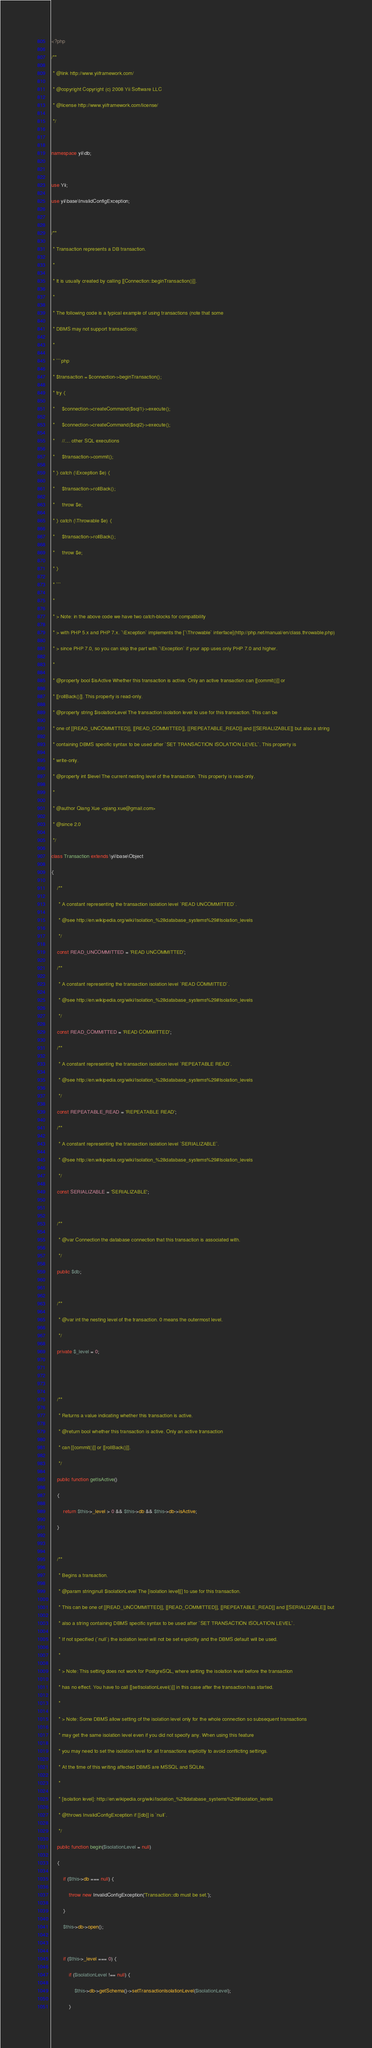Convert code to text. <code><loc_0><loc_0><loc_500><loc_500><_PHP_><?php
/**
 * @link http://www.yiiframework.com/
 * @copyright Copyright (c) 2008 Yii Software LLC
 * @license http://www.yiiframework.com/license/
 */

namespace yii\db;

use Yii;
use yii\base\InvalidConfigException;

/**
 * Transaction represents a DB transaction.
 *
 * It is usually created by calling [[Connection::beginTransaction()]].
 *
 * The following code is a typical example of using transactions (note that some
 * DBMS may not support transactions):
 *
 * ```php
 * $transaction = $connection->beginTransaction();
 * try {
 *     $connection->createCommand($sql1)->execute();
 *     $connection->createCommand($sql2)->execute();
 *     //.... other SQL executions
 *     $transaction->commit();
 * } catch (\Exception $e) {
 *     $transaction->rollBack();
 *     throw $e;
 * } catch (\Throwable $e) {
 *     $transaction->rollBack();
 *     throw $e;
 * }
 * ```
 *
 * > Note: in the above code we have two catch-blocks for compatibility
 * > with PHP 5.x and PHP 7.x. `\Exception` implements the [`\Throwable` interface](http://php.net/manual/en/class.throwable.php)
 * > since PHP 7.0, so you can skip the part with `\Exception` if your app uses only PHP 7.0 and higher.
 *
 * @property bool $isActive Whether this transaction is active. Only an active transaction can [[commit()]] or
 * [[rollBack()]]. This property is read-only.
 * @property string $isolationLevel The transaction isolation level to use for this transaction. This can be
 * one of [[READ_UNCOMMITTED]], [[READ_COMMITTED]], [[REPEATABLE_READ]] and [[SERIALIZABLE]] but also a string
 * containing DBMS specific syntax to be used after `SET TRANSACTION ISOLATION LEVEL`. This property is
 * write-only.
 * @property int $level The current nesting level of the transaction. This property is read-only.
 *
 * @author Qiang Xue <qiang.xue@gmail.com>
 * @since 2.0
 */
class Transaction extends \yii\base\Object
{
    /**
     * A constant representing the transaction isolation level `READ UNCOMMITTED`.
     * @see http://en.wikipedia.org/wiki/Isolation_%28database_systems%29#Isolation_levels
     */
    const READ_UNCOMMITTED = 'READ UNCOMMITTED';
    /**
     * A constant representing the transaction isolation level `READ COMMITTED`.
     * @see http://en.wikipedia.org/wiki/Isolation_%28database_systems%29#Isolation_levels
     */
    const READ_COMMITTED = 'READ COMMITTED';
    /**
     * A constant representing the transaction isolation level `REPEATABLE READ`.
     * @see http://en.wikipedia.org/wiki/Isolation_%28database_systems%29#Isolation_levels
     */
    const REPEATABLE_READ = 'REPEATABLE READ';
    /**
     * A constant representing the transaction isolation level `SERIALIZABLE`.
     * @see http://en.wikipedia.org/wiki/Isolation_%28database_systems%29#Isolation_levels
     */
    const SERIALIZABLE = 'SERIALIZABLE';

    /**
     * @var Connection the database connection that this transaction is associated with.
     */
    public $db;

    /**
     * @var int the nesting level of the transaction. 0 means the outermost level.
     */
    private $_level = 0;


    /**
     * Returns a value indicating whether this transaction is active.
     * @return bool whether this transaction is active. Only an active transaction
     * can [[commit()]] or [[rollBack()]].
     */
    public function getIsActive()
    {
        return $this->_level > 0 && $this->db && $this->db->isActive;
    }

    /**
     * Begins a transaction.
     * @param string|null $isolationLevel The [isolation level][] to use for this transaction.
     * This can be one of [[READ_UNCOMMITTED]], [[READ_COMMITTED]], [[REPEATABLE_READ]] and [[SERIALIZABLE]] but
     * also a string containing DBMS specific syntax to be used after `SET TRANSACTION ISOLATION LEVEL`.
     * If not specified (`null`) the isolation level will not be set explicitly and the DBMS default will be used.
     *
     * > Note: This setting does not work for PostgreSQL, where setting the isolation level before the transaction
     * has no effect. You have to call [[setIsolationLevel()]] in this case after the transaction has started.
     *
     * > Note: Some DBMS allow setting of the isolation level only for the whole connection so subsequent transactions
     * may get the same isolation level even if you did not specify any. When using this feature
     * you may need to set the isolation level for all transactions explicitly to avoid conflicting settings.
     * At the time of this writing affected DBMS are MSSQL and SQLite.
     *
     * [isolation level]: http://en.wikipedia.org/wiki/Isolation_%28database_systems%29#Isolation_levels
     * @throws InvalidConfigException if [[db]] is `null`.
     */
    public function begin($isolationLevel = null)
    {
        if ($this->db === null) {
            throw new InvalidConfigException('Transaction::db must be set.');
        }
        $this->db->open();

        if ($this->_level === 0) {
            if ($isolationLevel !== null) {
                $this->db->getSchema()->setTransactionIsolationLevel($isolationLevel);
            }</code> 